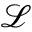<formula> <loc_0><loc_0><loc_500><loc_500>\mathcal { L }</formula> 